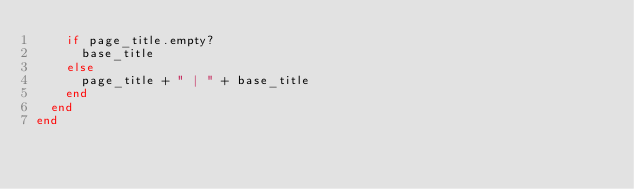Convert code to text. <code><loc_0><loc_0><loc_500><loc_500><_Ruby_>    if page_title.empty?
      base_title
    else
      page_title + " | " + base_title
    end
  end  
end
</code> 